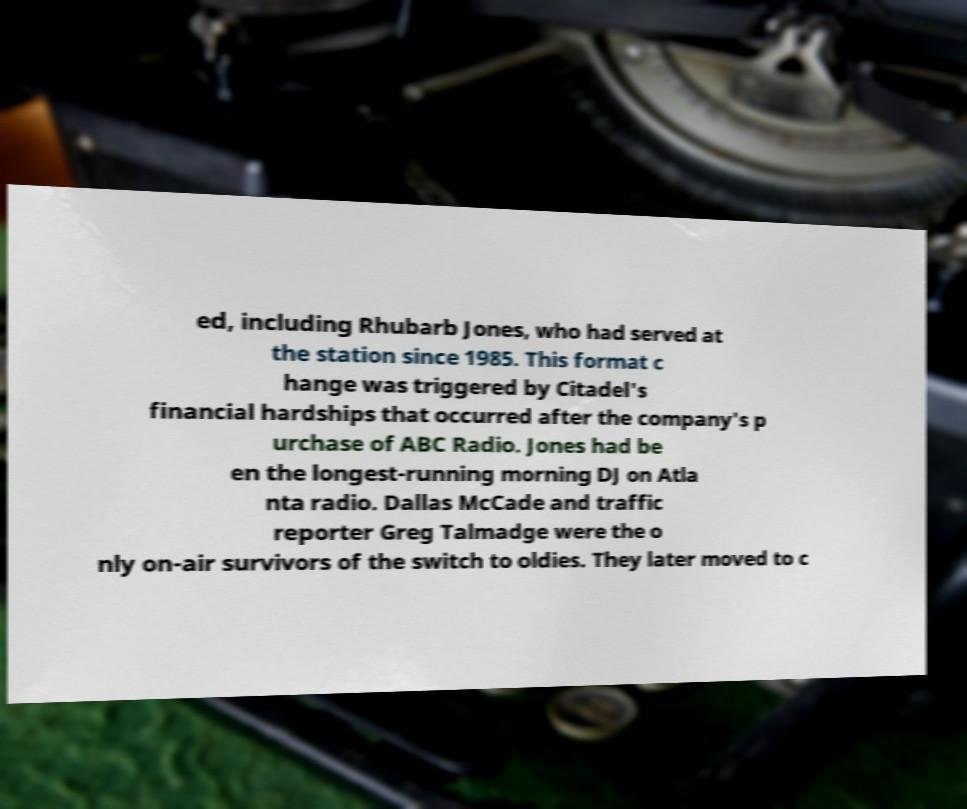Please identify and transcribe the text found in this image. ed, including Rhubarb Jones, who had served at the station since 1985. This format c hange was triggered by Citadel's financial hardships that occurred after the company's p urchase of ABC Radio. Jones had be en the longest-running morning DJ on Atla nta radio. Dallas McCade and traffic reporter Greg Talmadge were the o nly on-air survivors of the switch to oldies. They later moved to c 